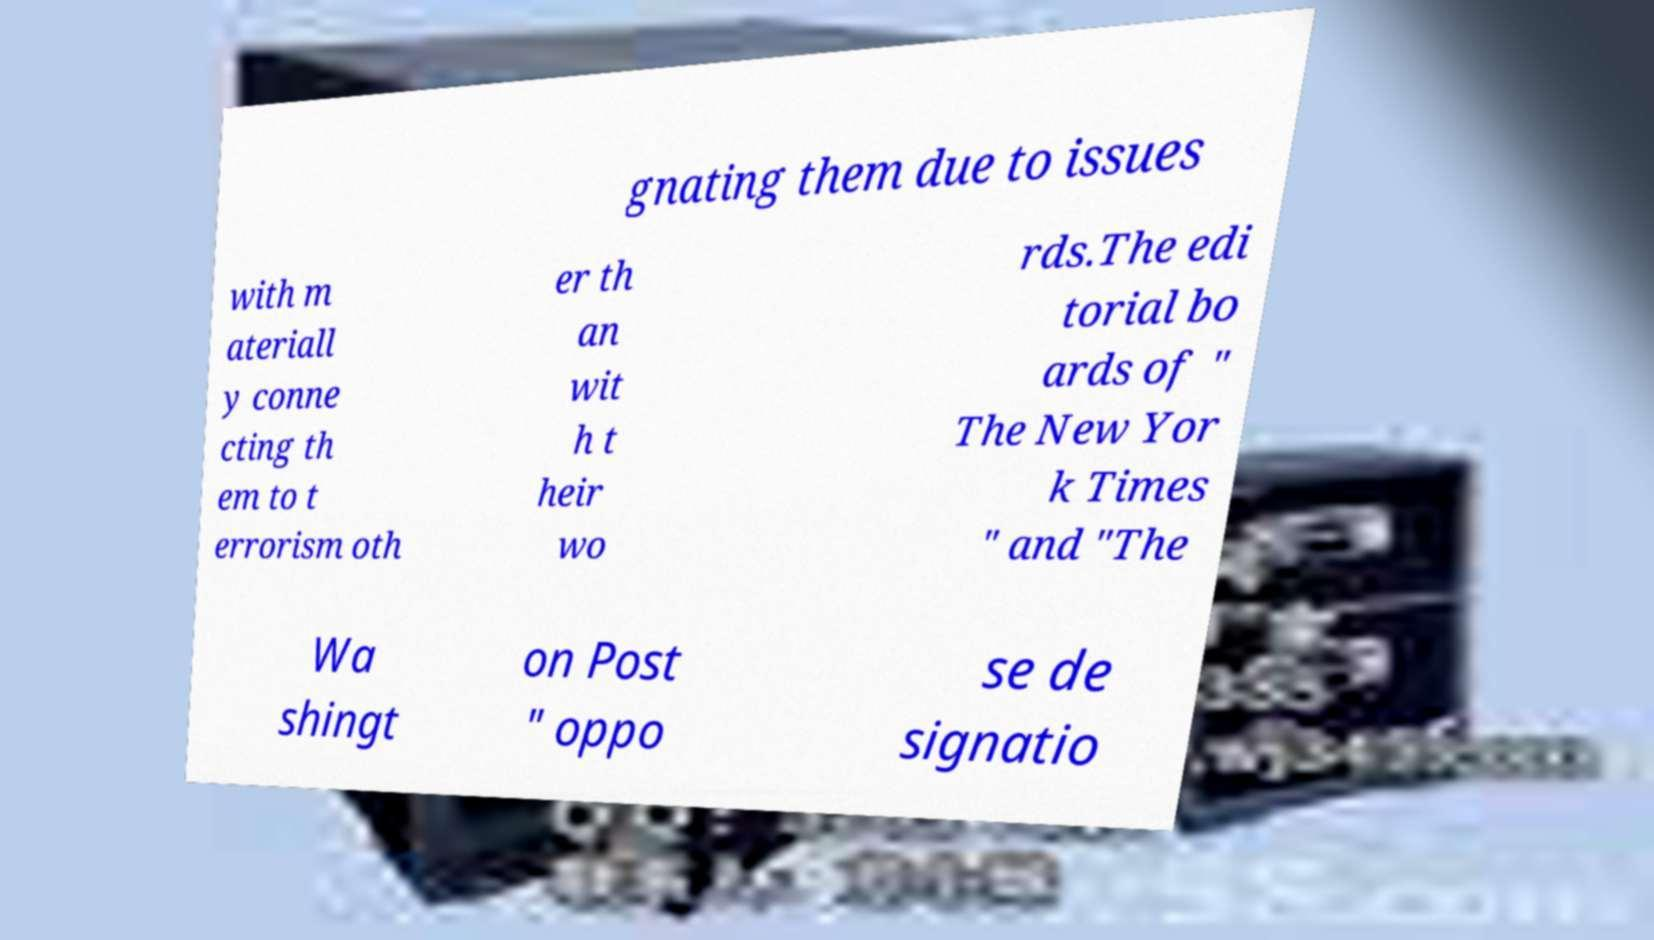Could you assist in decoding the text presented in this image and type it out clearly? gnating them due to issues with m ateriall y conne cting th em to t errorism oth er th an wit h t heir wo rds.The edi torial bo ards of " The New Yor k Times " and "The Wa shingt on Post " oppo se de signatio 